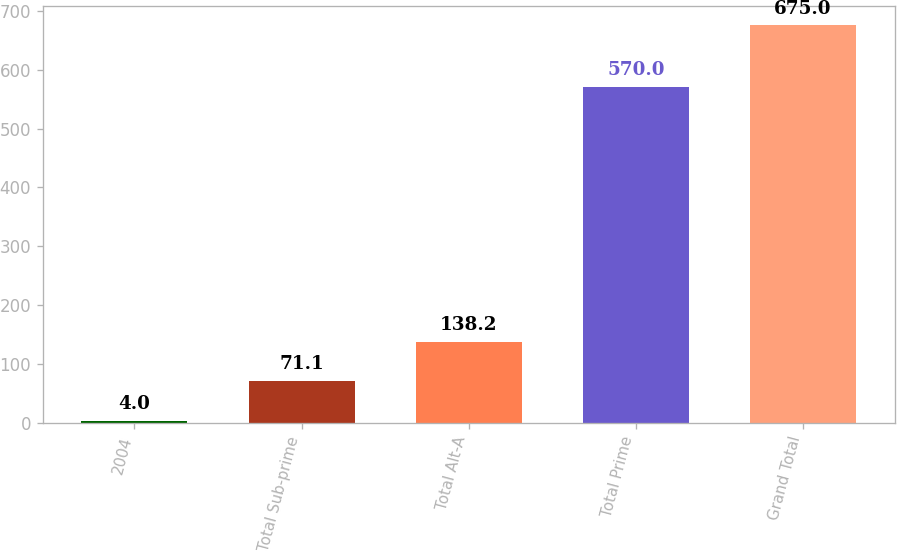<chart> <loc_0><loc_0><loc_500><loc_500><bar_chart><fcel>2004<fcel>Total Sub-prime<fcel>Total Alt-A<fcel>Total Prime<fcel>Grand Total<nl><fcel>4<fcel>71.1<fcel>138.2<fcel>570<fcel>675<nl></chart> 